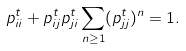Convert formula to latex. <formula><loc_0><loc_0><loc_500><loc_500>p _ { i i } ^ { t } + p _ { i j } ^ { t } p _ { j i } ^ { t } \sum _ { n \geq 1 } ( p _ { j j } ^ { t } ) ^ { n } = 1 .</formula> 